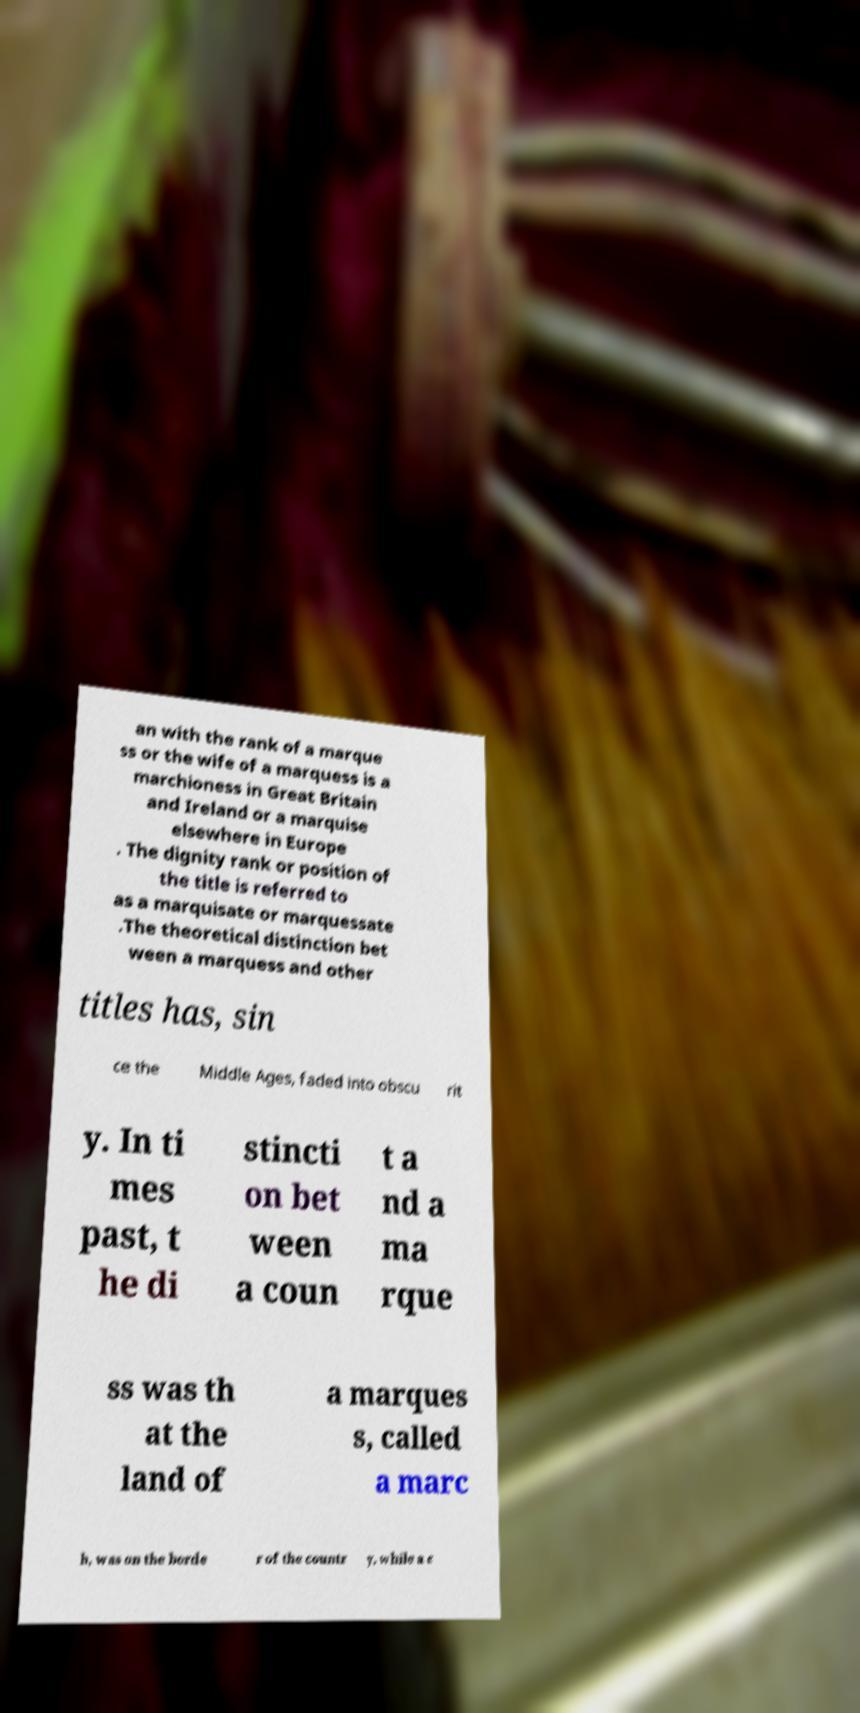What messages or text are displayed in this image? I need them in a readable, typed format. an with the rank of a marque ss or the wife of a marquess is a marchioness in Great Britain and Ireland or a marquise elsewhere in Europe . The dignity rank or position of the title is referred to as a marquisate or marquessate .The theoretical distinction bet ween a marquess and other titles has, sin ce the Middle Ages, faded into obscu rit y. In ti mes past, t he di stincti on bet ween a coun t a nd a ma rque ss was th at the land of a marques s, called a marc h, was on the borde r of the countr y, while a c 